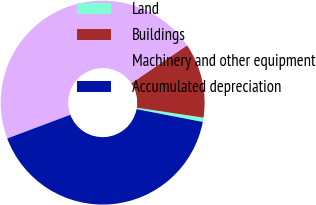<chart> <loc_0><loc_0><loc_500><loc_500><pie_chart><fcel>Land<fcel>Buildings<fcel>Machinery and other equipment<fcel>Accumulated depreciation<nl><fcel>0.68%<fcel>11.85%<fcel>46.23%<fcel>41.23%<nl></chart> 